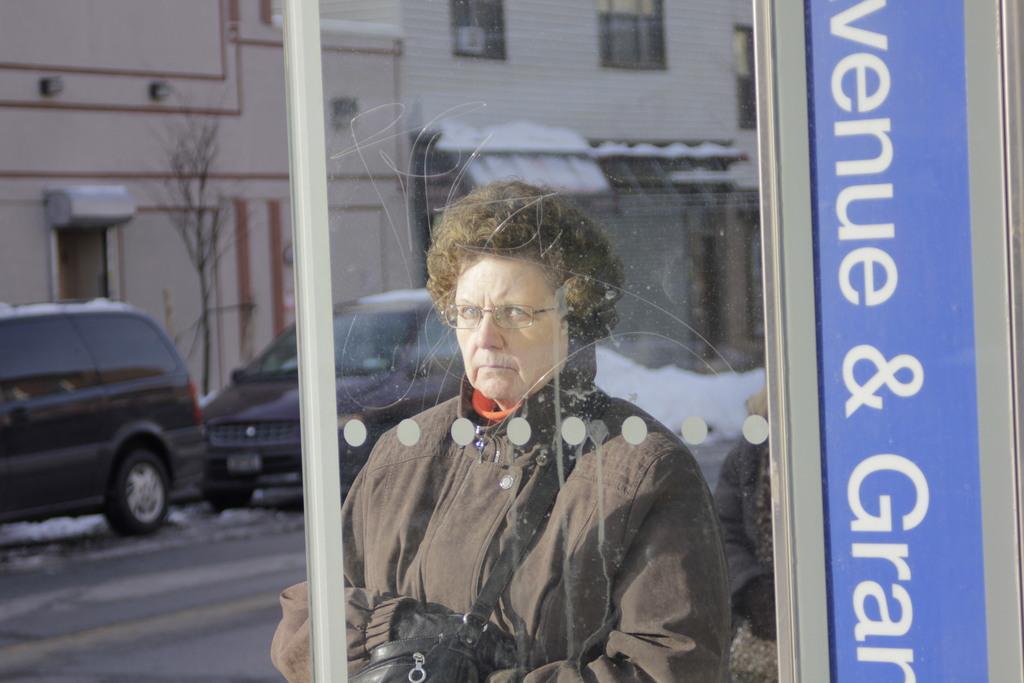In one or two sentences, can you explain what this image depicts? In this image we can see a woman wearing a coat and carrying a bag with spectacles. In the background, we can see group of vehicles parked on the ground, buildings and trees. 